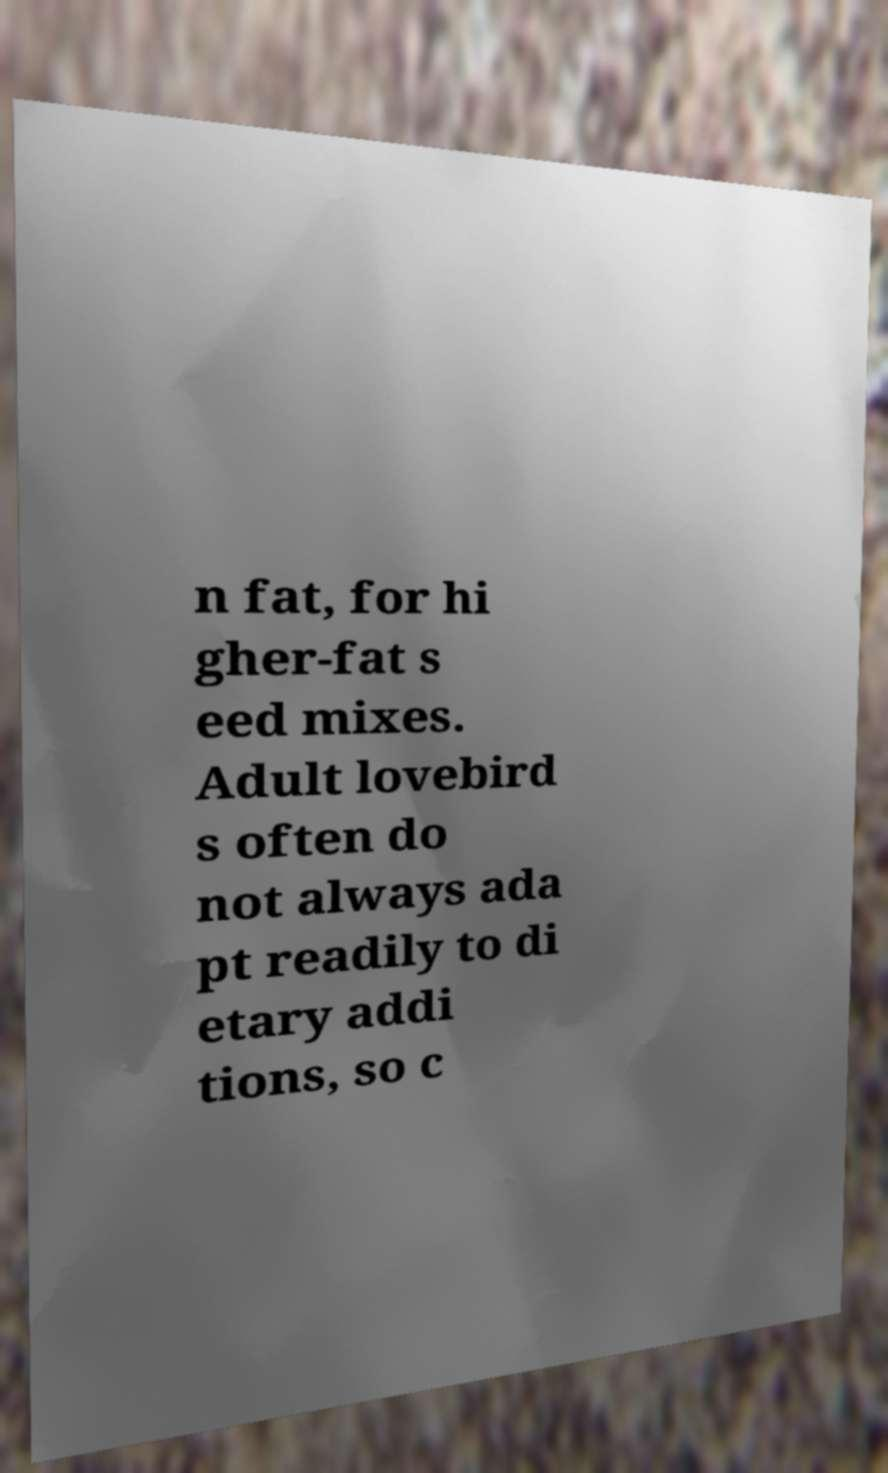Could you assist in decoding the text presented in this image and type it out clearly? n fat, for hi gher-fat s eed mixes. Adult lovebird s often do not always ada pt readily to di etary addi tions, so c 